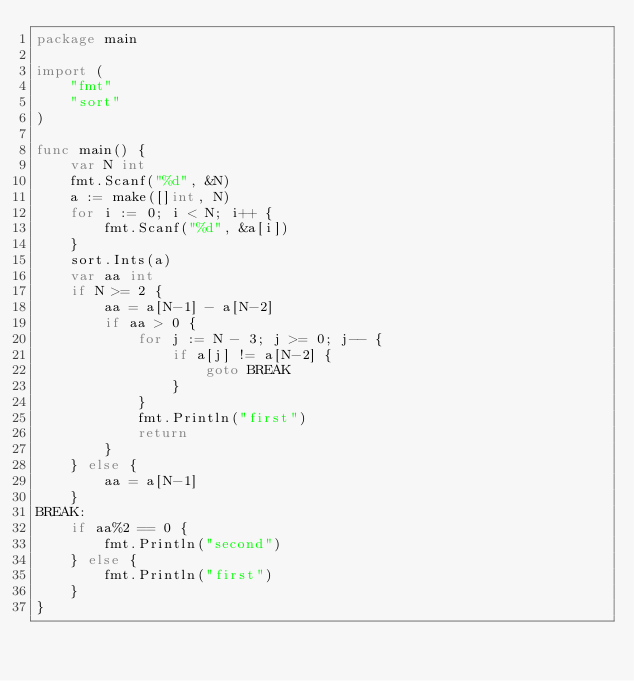<code> <loc_0><loc_0><loc_500><loc_500><_Go_>package main

import (
	"fmt"
	"sort"
)

func main() {
	var N int
	fmt.Scanf("%d", &N)
	a := make([]int, N)
	for i := 0; i < N; i++ {
		fmt.Scanf("%d", &a[i])
	}
	sort.Ints(a)
	var aa int
	if N >= 2 {
		aa = a[N-1] - a[N-2]
		if aa > 0 {
			for j := N - 3; j >= 0; j-- {
				if a[j] != a[N-2] {
					goto BREAK
				}
			}
			fmt.Println("first")
			return
		}
	} else {
		aa = a[N-1]
	}
BREAK:
	if aa%2 == 0 {
		fmt.Println("second")
	} else {
		fmt.Println("first")
	}
}
</code> 